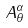Convert formula to latex. <formula><loc_0><loc_0><loc_500><loc_500>A _ { \theta } ^ { \alpha }</formula> 